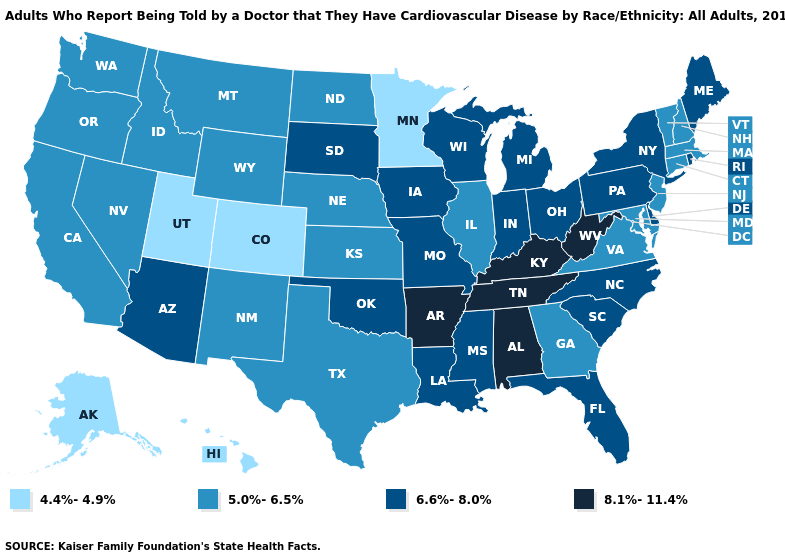Does Iowa have the lowest value in the USA?
Give a very brief answer. No. Does Connecticut have the lowest value in the Northeast?
Write a very short answer. Yes. What is the lowest value in the USA?
Short answer required. 4.4%-4.9%. Name the states that have a value in the range 6.6%-8.0%?
Answer briefly. Arizona, Delaware, Florida, Indiana, Iowa, Louisiana, Maine, Michigan, Mississippi, Missouri, New York, North Carolina, Ohio, Oklahoma, Pennsylvania, Rhode Island, South Carolina, South Dakota, Wisconsin. Which states have the lowest value in the West?
Quick response, please. Alaska, Colorado, Hawaii, Utah. Among the states that border Montana , does North Dakota have the lowest value?
Concise answer only. Yes. What is the value of Minnesota?
Short answer required. 4.4%-4.9%. What is the lowest value in the Northeast?
Quick response, please. 5.0%-6.5%. What is the value of Kentucky?
Keep it brief. 8.1%-11.4%. Which states have the lowest value in the USA?
Give a very brief answer. Alaska, Colorado, Hawaii, Minnesota, Utah. What is the value of South Dakota?
Short answer required. 6.6%-8.0%. Does Kentucky have the lowest value in the South?
Concise answer only. No. What is the lowest value in states that border Pennsylvania?
Keep it brief. 5.0%-6.5%. Does Massachusetts have the lowest value in the Northeast?
Keep it brief. Yes. Among the states that border North Dakota , which have the lowest value?
Be succinct. Minnesota. 